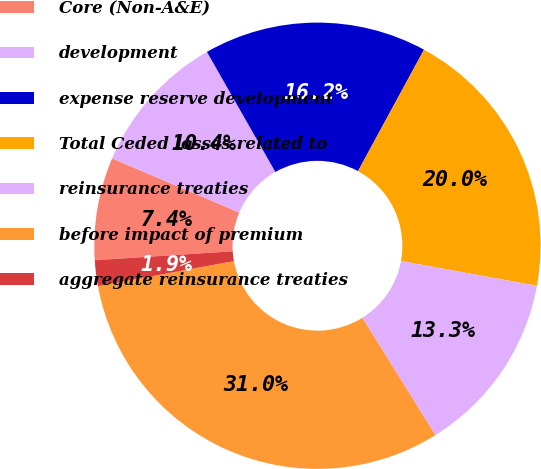<chart> <loc_0><loc_0><loc_500><loc_500><pie_chart><fcel>Core (Non-A&E)<fcel>development<fcel>expense reserve development<fcel>Total Ceded losses related to<fcel>reinsurance treaties<fcel>before impact of premium<fcel>aggregate reinsurance treaties<nl><fcel>7.44%<fcel>10.35%<fcel>16.17%<fcel>19.95%<fcel>13.26%<fcel>30.97%<fcel>1.86%<nl></chart> 